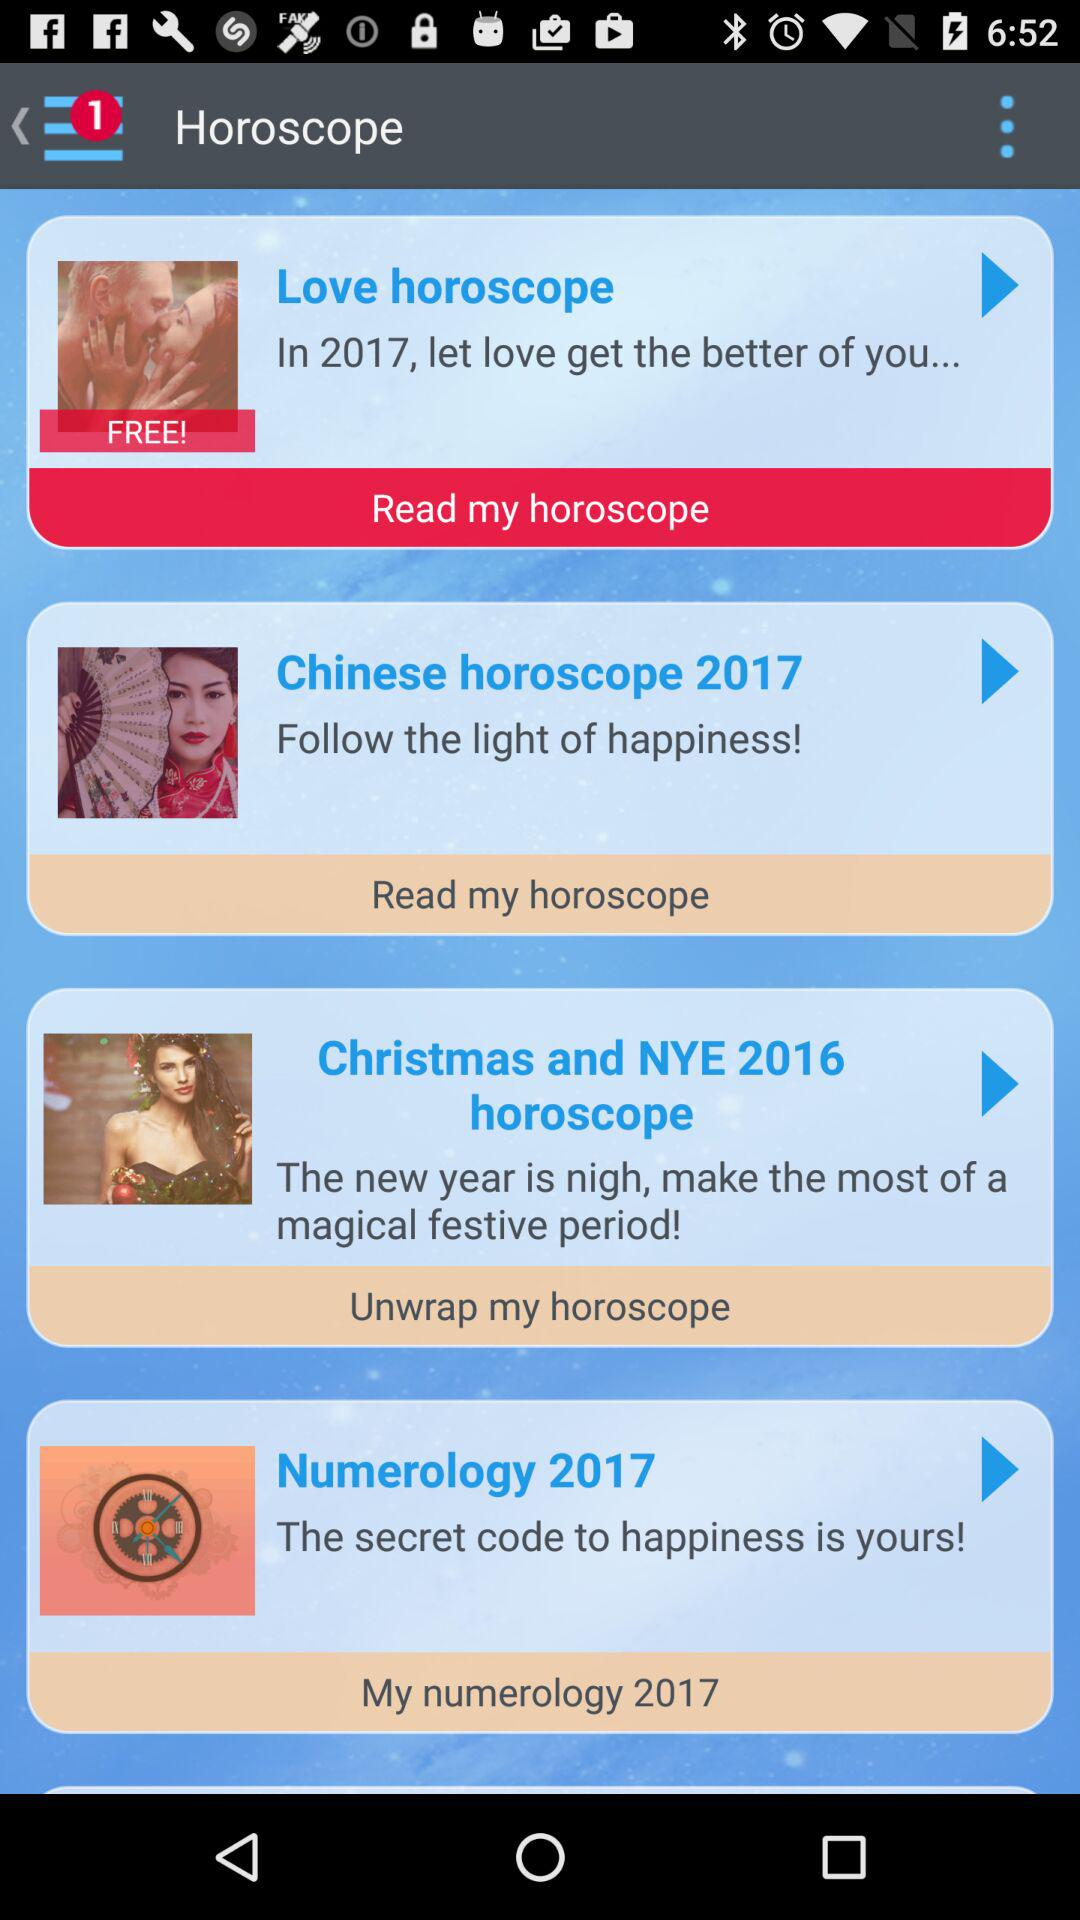What is the application name?
When the provided information is insufficient, respond with <no answer>. <no answer> 